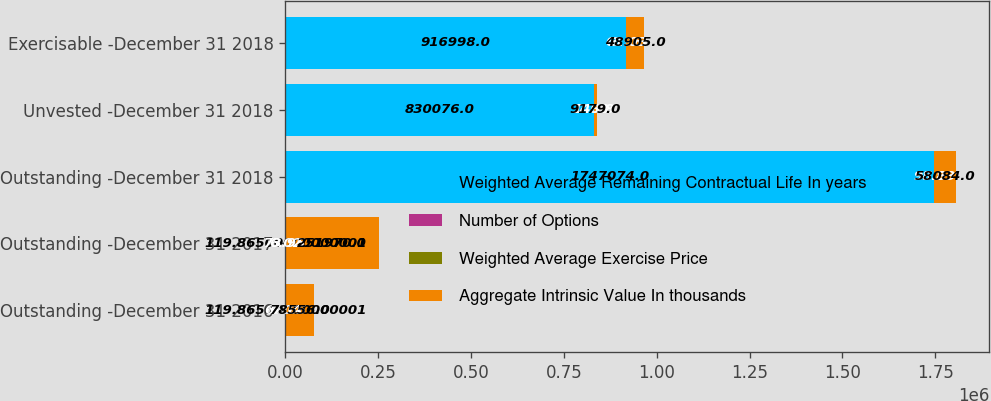Convert chart. <chart><loc_0><loc_0><loc_500><loc_500><stacked_bar_chart><ecel><fcel>Outstanding -December 31 2016<fcel>Outstanding -December 31 2017<fcel>Outstanding -December 31 2018<fcel>Unvested -December 31 2018<fcel>Exercisable -December 31 2018<nl><fcel>Weighted Average Remaining Contractual Life In years<fcel>119.865<fcel>119.865<fcel>1.74707e+06<fcel>830076<fcel>916998<nl><fcel>Number of Options<fcel>60.65<fcel>73.95<fcel>98.93<fcel>140.8<fcel>61.03<nl><fcel>Weighted Average Exercise Price<fcel>6.04<fcel>6.02<fcel>5.8<fcel>7.82<fcel>3.96<nl><fcel>Aggregate Intrinsic Value In thousands<fcel>78556<fcel>251970<fcel>58084<fcel>9179<fcel>48905<nl></chart> 